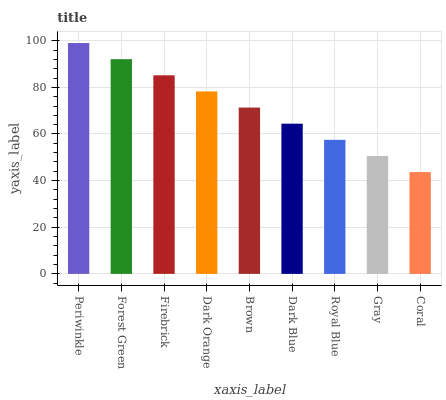Is Coral the minimum?
Answer yes or no. Yes. Is Periwinkle the maximum?
Answer yes or no. Yes. Is Forest Green the minimum?
Answer yes or no. No. Is Forest Green the maximum?
Answer yes or no. No. Is Periwinkle greater than Forest Green?
Answer yes or no. Yes. Is Forest Green less than Periwinkle?
Answer yes or no. Yes. Is Forest Green greater than Periwinkle?
Answer yes or no. No. Is Periwinkle less than Forest Green?
Answer yes or no. No. Is Brown the high median?
Answer yes or no. Yes. Is Brown the low median?
Answer yes or no. Yes. Is Firebrick the high median?
Answer yes or no. No. Is Dark Blue the low median?
Answer yes or no. No. 